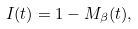<formula> <loc_0><loc_0><loc_500><loc_500>I ( t ) = 1 - M _ { \beta } ( t ) ,</formula> 